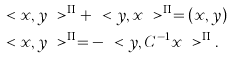Convert formula to latex. <formula><loc_0><loc_0><loc_500><loc_500>& \ < x , y \ > ^ { \Pi } + \ < y , x \ > ^ { \Pi } = ( x , y ) \\ & \ < x , y \ > ^ { \Pi } = - \ < y , C ^ { - 1 } x \ > ^ { \Pi } .</formula> 